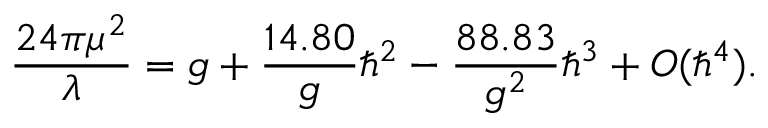<formula> <loc_0><loc_0><loc_500><loc_500>{ \frac { 2 4 \pi \mu ^ { 2 } } { \lambda } } = g + { \frac { 1 4 . 8 0 } { g } } \hbar { ^ } { 2 } - { \frac { 8 8 . 8 3 } { g ^ { 2 } } } \hbar { ^ } { 3 } + O ( \hbar { ^ } { 4 } ) .</formula> 